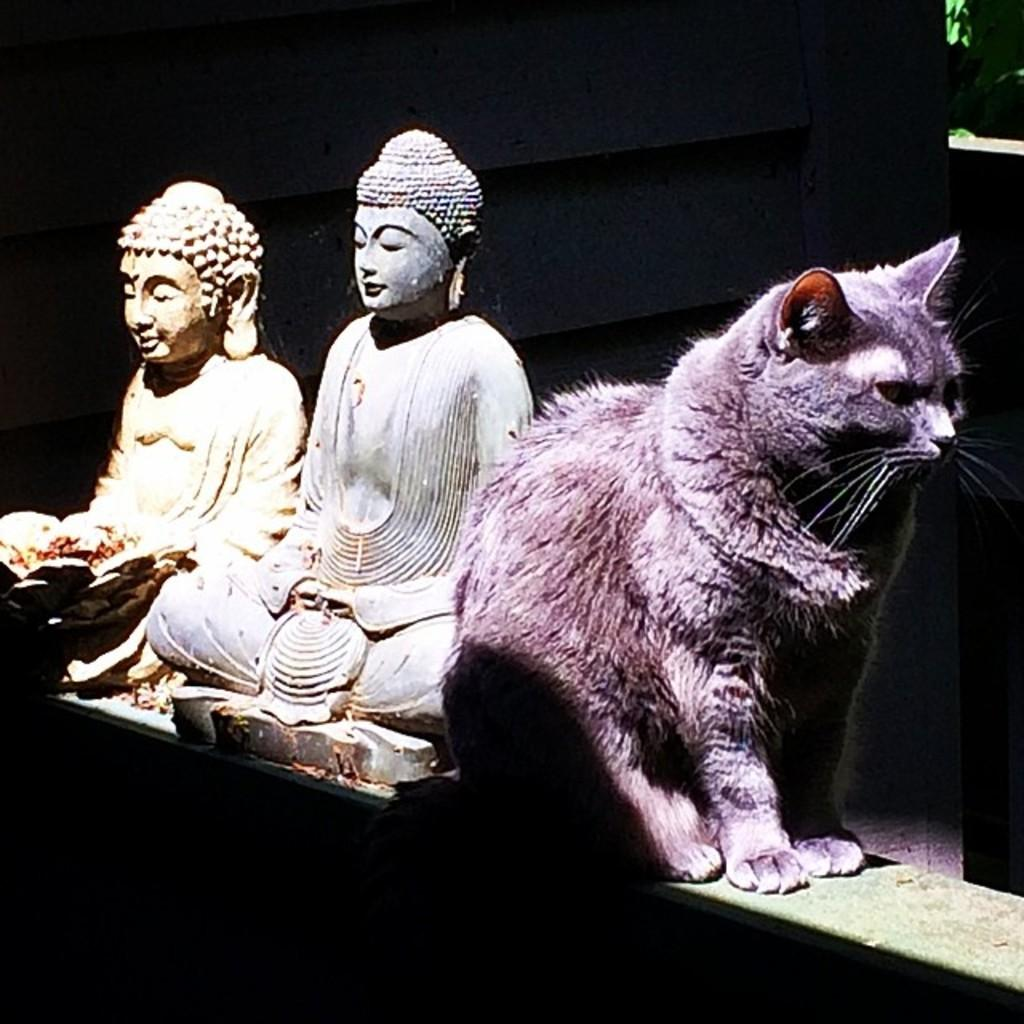What type of animal is present in the image? There is a cat in the image. Where is the cat located in relation to other objects in the image? The cat is sitting beside buddha sculptures. What type of rod can be seen holding up the duck in the image? There is no rod or duck present in the image; it only features a cat sitting beside buddha sculptures. 